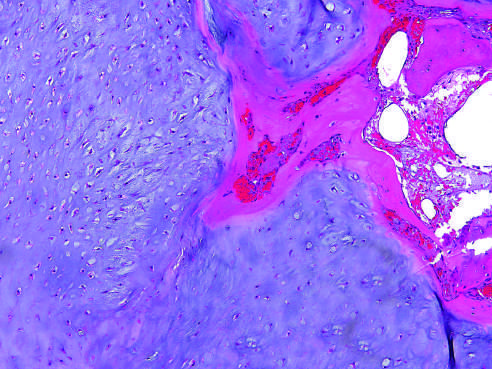what is enchondroma composed of?
Answer the question using a single word or phrase. A nodule of hyaline cartilage 